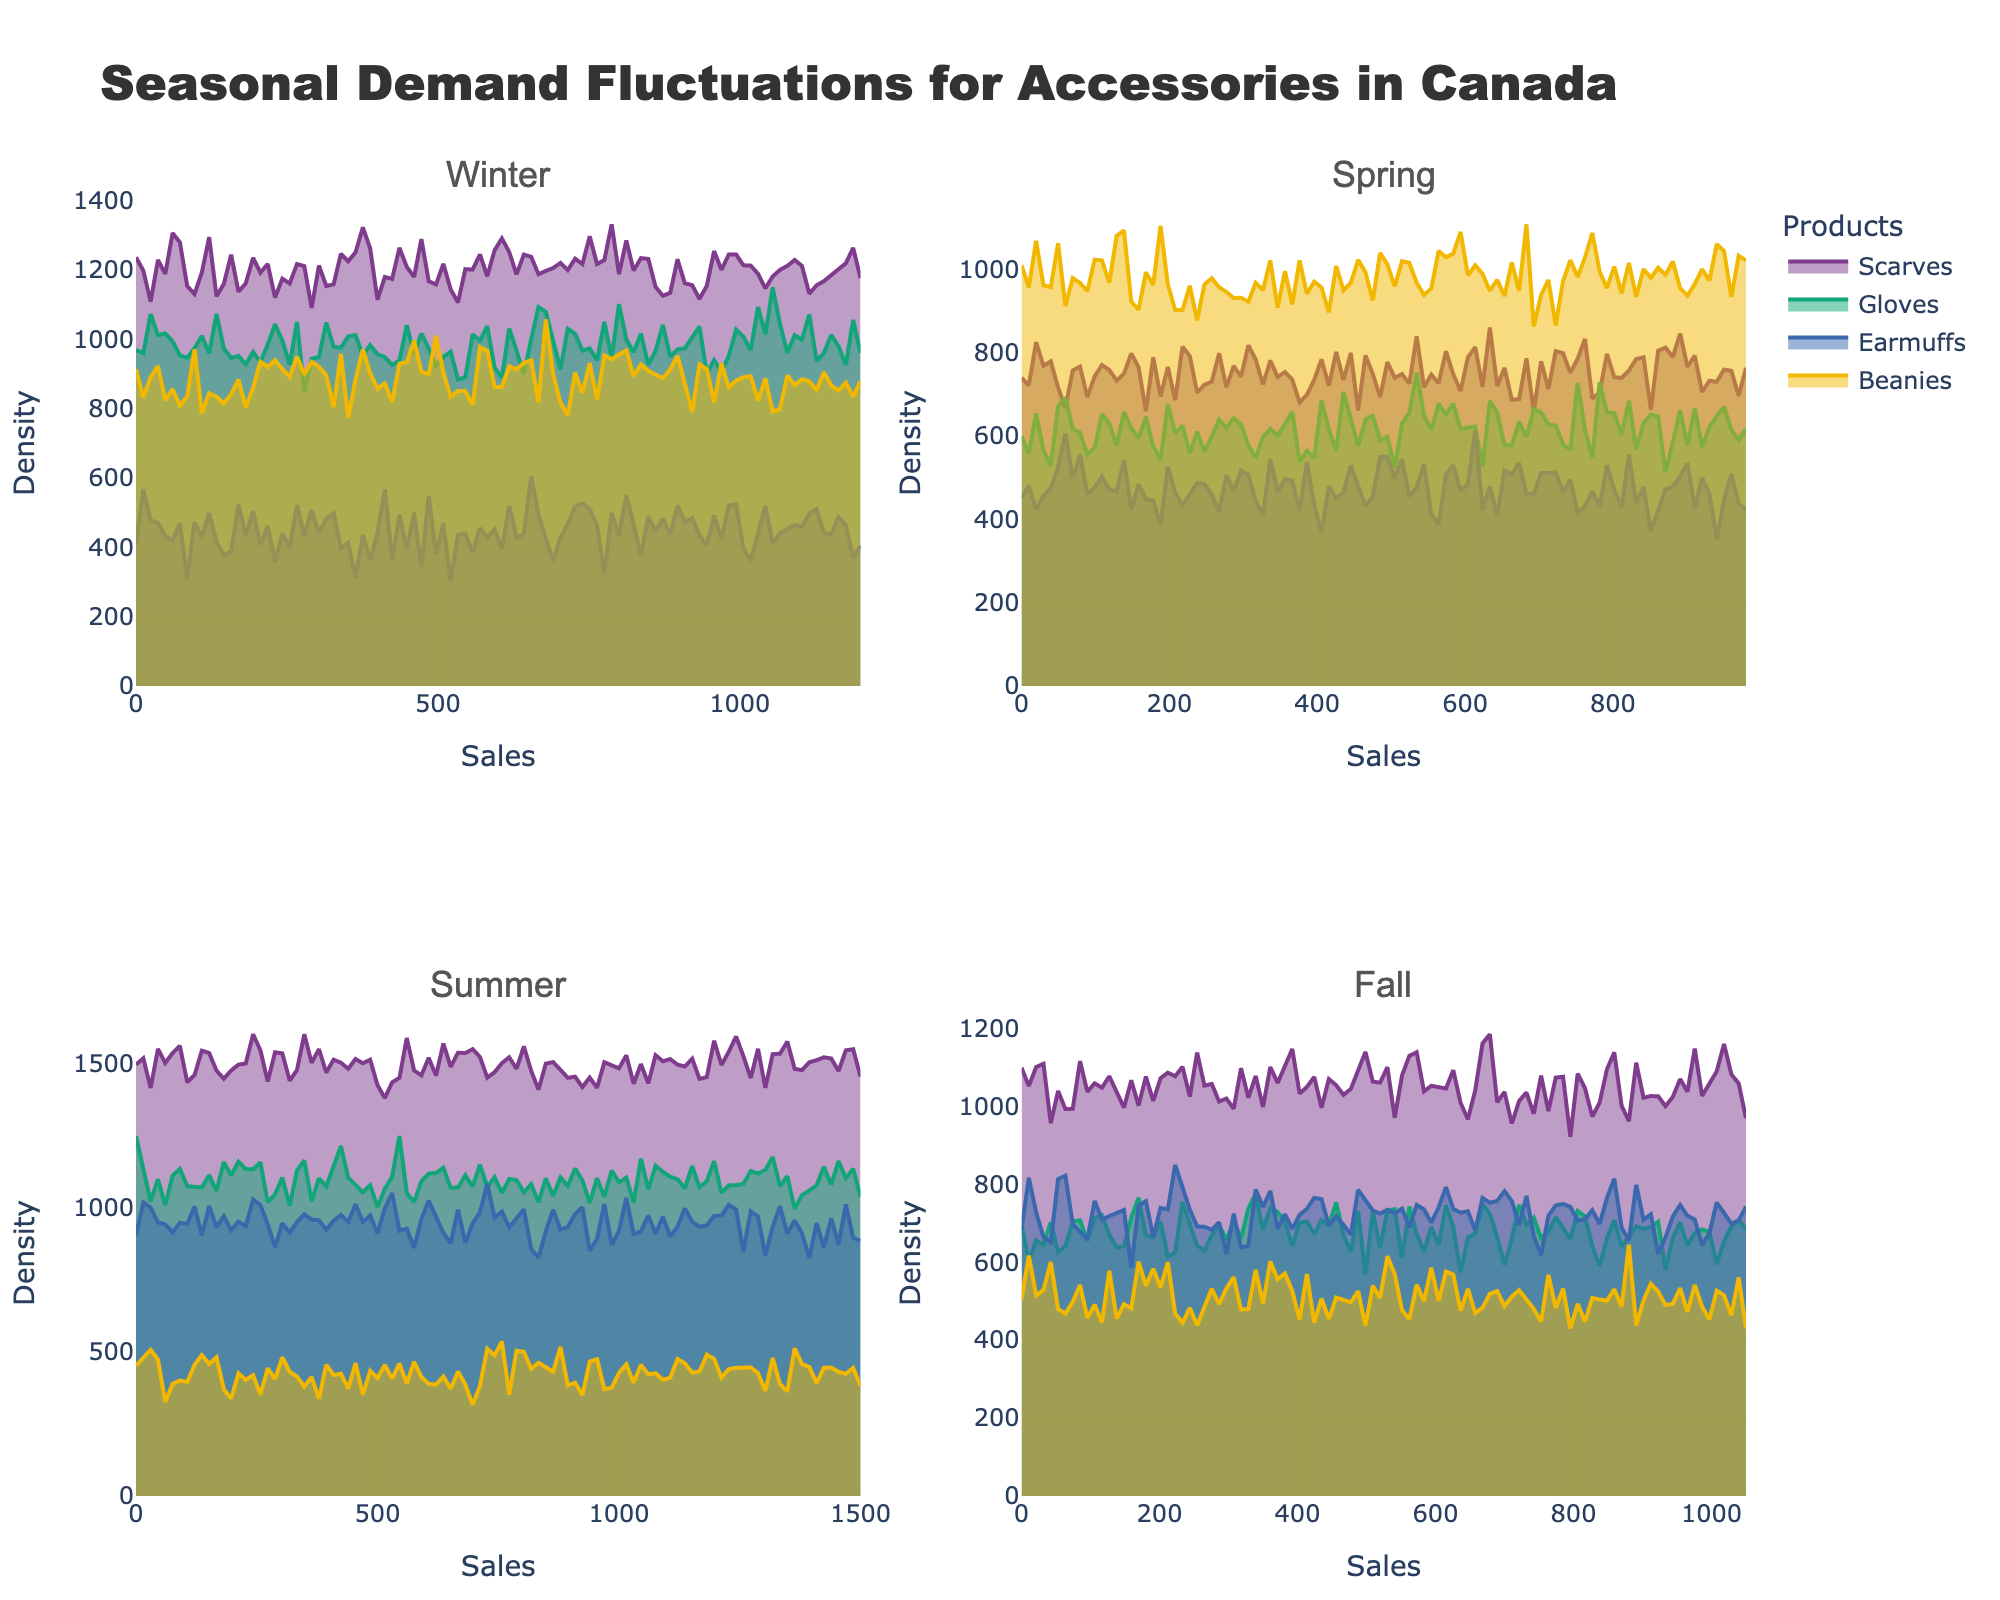What is the title of the figure? Look at the top of the figure. The title is usually centrally positioned at the top.
Answer: Seasonal Demand Fluctuations for Accessories in Canada In which season is Sunglasses the most in demand? Identify the subplot labeled with "Summer". Look for the product "Sunglasses" and note its high density line compared to other seasons.
Answer: Summer What product has the highest demand in Fall? Check the subplot labeled "Fall" and identify which product has the highest sales density.
Answer: Handbags How do the densities of Scarves in Winter compare to those in Spring? Check the subplots for Winter and Spring. Compare the density lines for Scarves in both seasons by noting their position along the sales axis.
Answer: Higher in Winter Which product shows a higher variation in demand in Winter: Gloves or Beanies? Look at the subplot labeled "Winter". Compare the spread of the density lines for Gloves and Beanies. Wider spread indicates higher variation.
Answer: Gloves What is the average sales value for products in Spring? Identify the sales values of all Spring products: Sunglasses (750), Hair Accessories (620), Lightweight Scarves (480), Jewelry (980). Sum these values and divide by the number of products. (750+620+480+980)/4 = 707.5
Answer: 707.5 Compare the density peaks of Wool Berets in Fall and Earmuffs in Winter. Which one has a higher peak? Check the subplots for Fall and Winter. Compare the density peak heights for Wool Berets and Earmuffs. Higher peak means higher density at a specific sales value.
Answer: Earmuffs What can be inferred about the demand for Sun Hats in Summer based on the plot? Examine the Summer subplot for Sun Hats. Look at the density line; if it's narrow and tall, the demand is consistent. If it's wide, the demand varies.
Answer: Consistent demand Which seasons have the lowest and highest product variety based on the subplots? Count the number of density lines (representing different products) in each season's subplot. The subplot with the fewest lines has the lowest variety, and the one with the most lines has the highest variety.
Answer: Lowest in Winter, Highest in Summer Which product shows the lowest sales density in Winter? Check the Winter subplot and identify which product has the shortest and least intense density line.
Answer: Earmuffs 